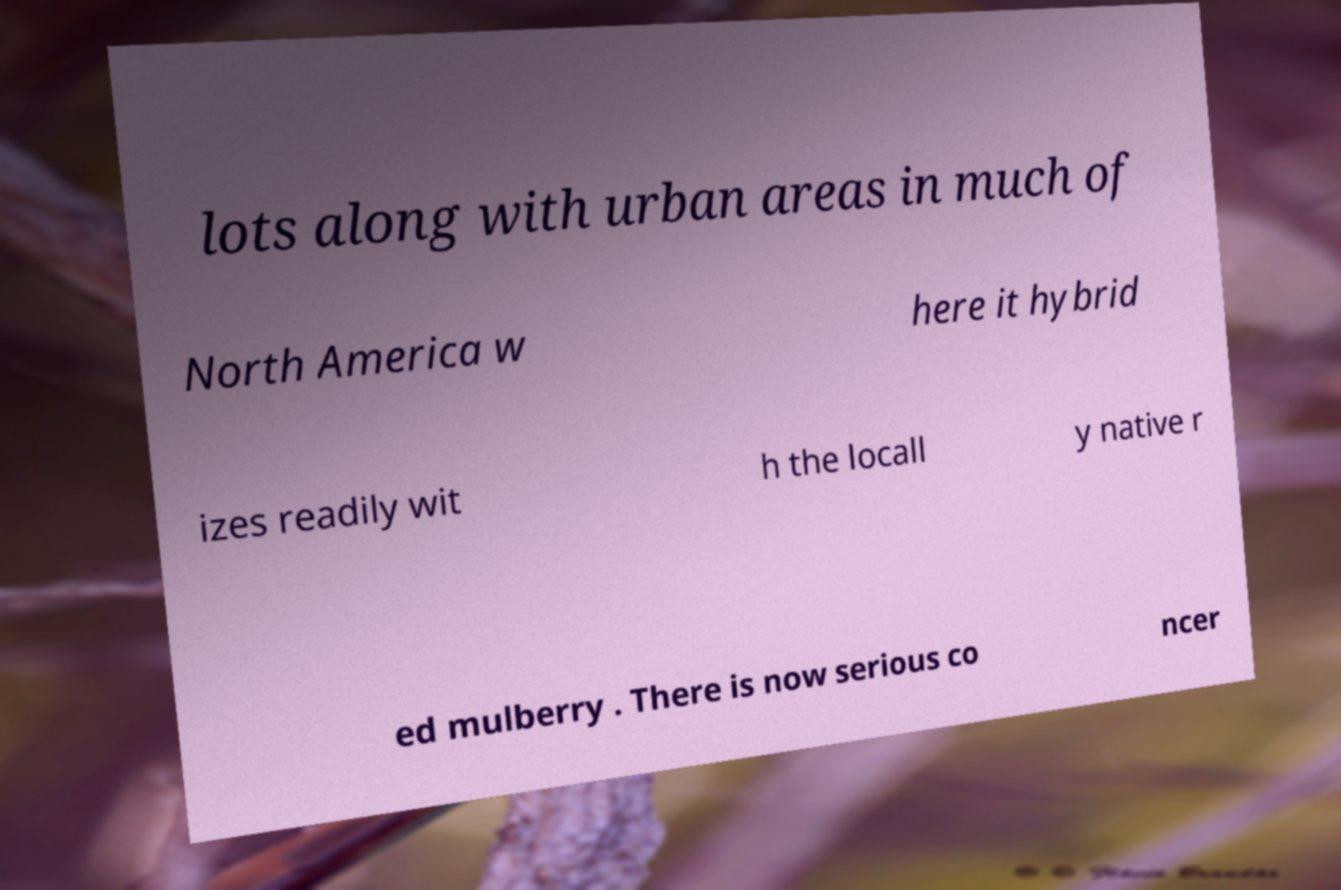I need the written content from this picture converted into text. Can you do that? lots along with urban areas in much of North America w here it hybrid izes readily wit h the locall y native r ed mulberry . There is now serious co ncer 